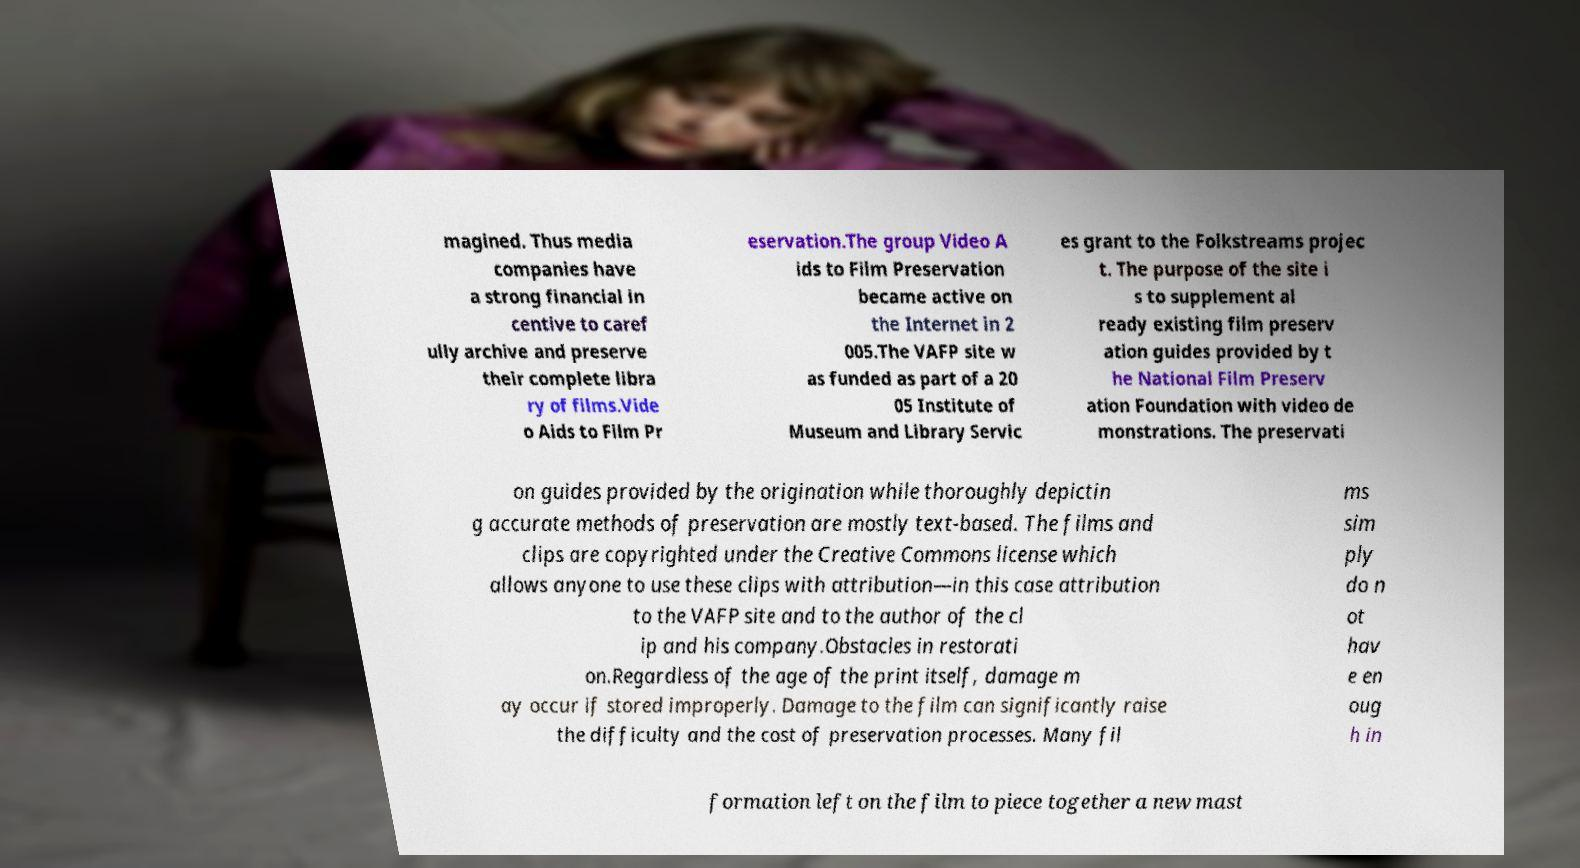Please identify and transcribe the text found in this image. magined. Thus media companies have a strong financial in centive to caref ully archive and preserve their complete libra ry of films.Vide o Aids to Film Pr eservation.The group Video A ids to Film Preservation became active on the Internet in 2 005.The VAFP site w as funded as part of a 20 05 Institute of Museum and Library Servic es grant to the Folkstreams projec t. The purpose of the site i s to supplement al ready existing film preserv ation guides provided by t he National Film Preserv ation Foundation with video de monstrations. The preservati on guides provided by the origination while thoroughly depictin g accurate methods of preservation are mostly text-based. The films and clips are copyrighted under the Creative Commons license which allows anyone to use these clips with attribution—in this case attribution to the VAFP site and to the author of the cl ip and his company.Obstacles in restorati on.Regardless of the age of the print itself, damage m ay occur if stored improperly. Damage to the film can significantly raise the difficulty and the cost of preservation processes. Many fil ms sim ply do n ot hav e en oug h in formation left on the film to piece together a new mast 